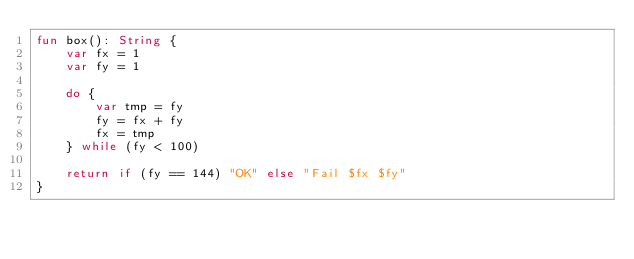<code> <loc_0><loc_0><loc_500><loc_500><_Kotlin_>fun box(): String {
    var fx = 1
    var fy = 1
    
    do {
        var tmp = fy
        fy = fx + fy
        fx = tmp
    } while (fy < 100)
    
    return if (fy == 144) "OK" else "Fail $fx $fy"
}
</code> 